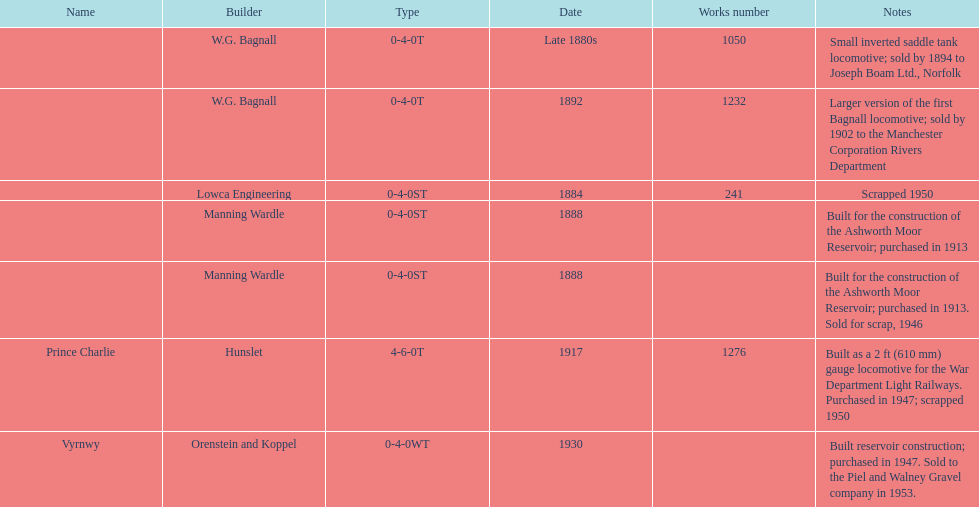How many trains were discarded? 3. 